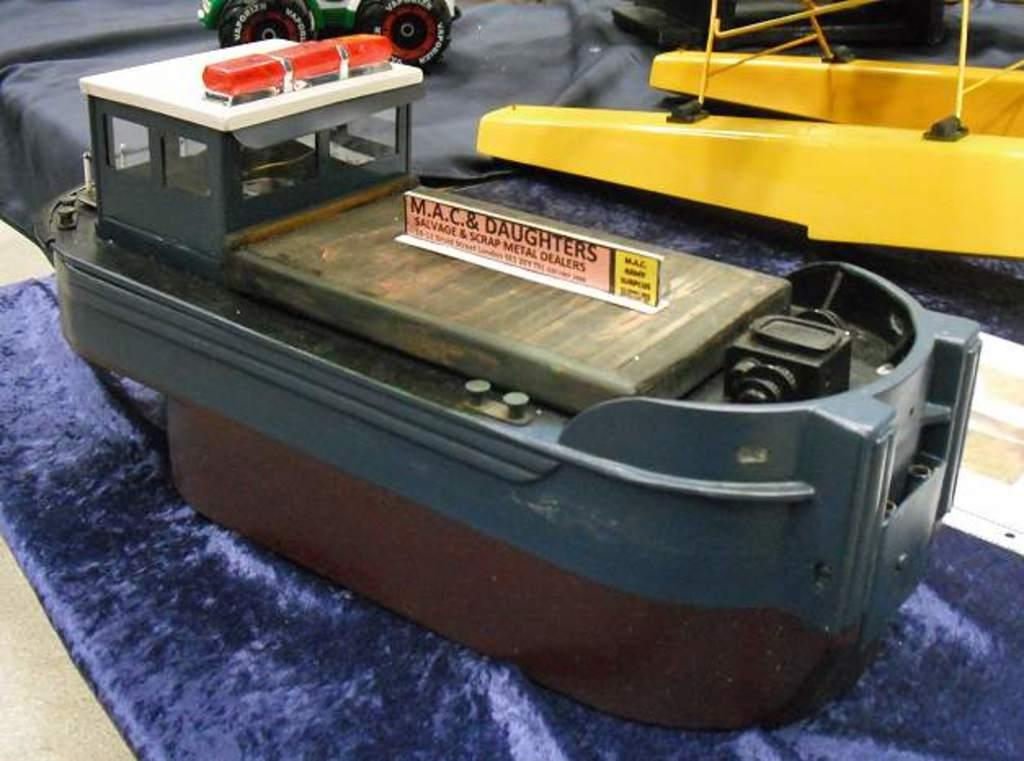What objects can be seen on the surface in the image? There are toys on the surface in the image. What is the board with text written on it used for in the image? The board with text written on it is likely used for displaying information or instructions. What type of paper items are present in the image? There are papers in the image. What color is the cloth in the image? The cloth in the image is blue. What is the rate of the skateboarder in the image? There is no skateboarder present in the image, so it is not possible to determine a rate. What story is being told by the toys in the image? The toys in the image are not telling a story; they are simply objects on the surface. 